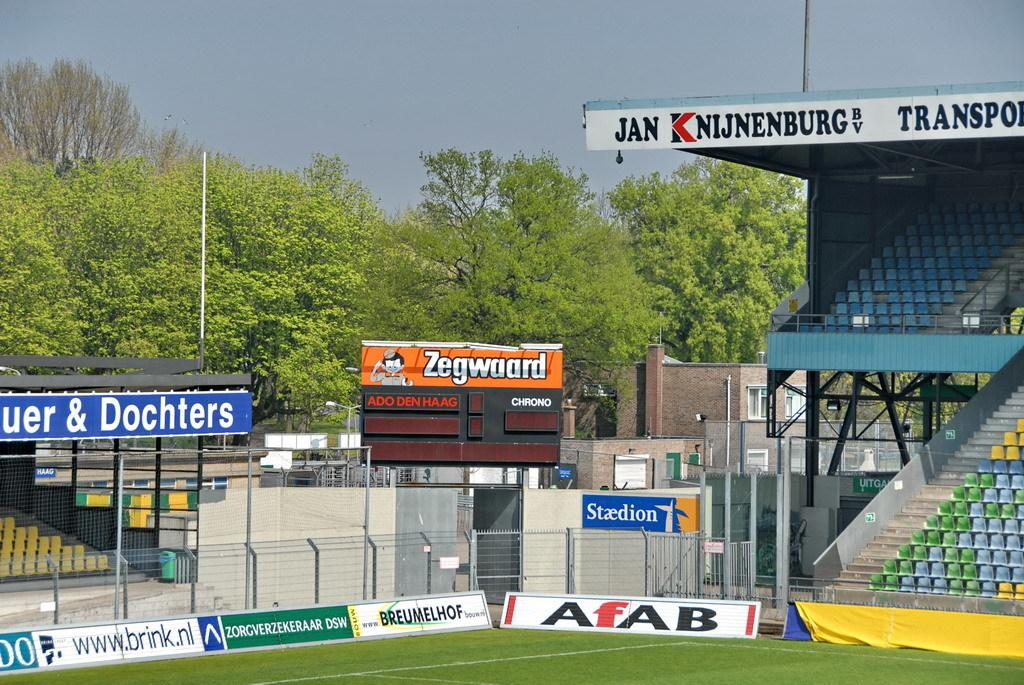<image>
Summarize the visual content of the image. A sports field of some sort sponsored by Zegwaard. 